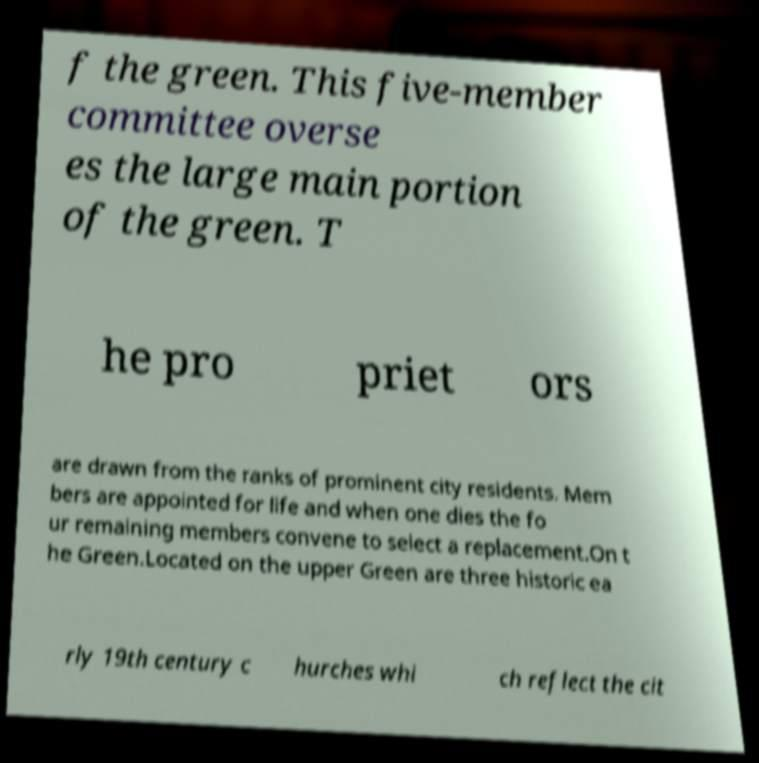Can you read and provide the text displayed in the image?This photo seems to have some interesting text. Can you extract and type it out for me? f the green. This five-member committee overse es the large main portion of the green. T he pro priet ors are drawn from the ranks of prominent city residents. Mem bers are appointed for life and when one dies the fo ur remaining members convene to select a replacement.On t he Green.Located on the upper Green are three historic ea rly 19th century c hurches whi ch reflect the cit 